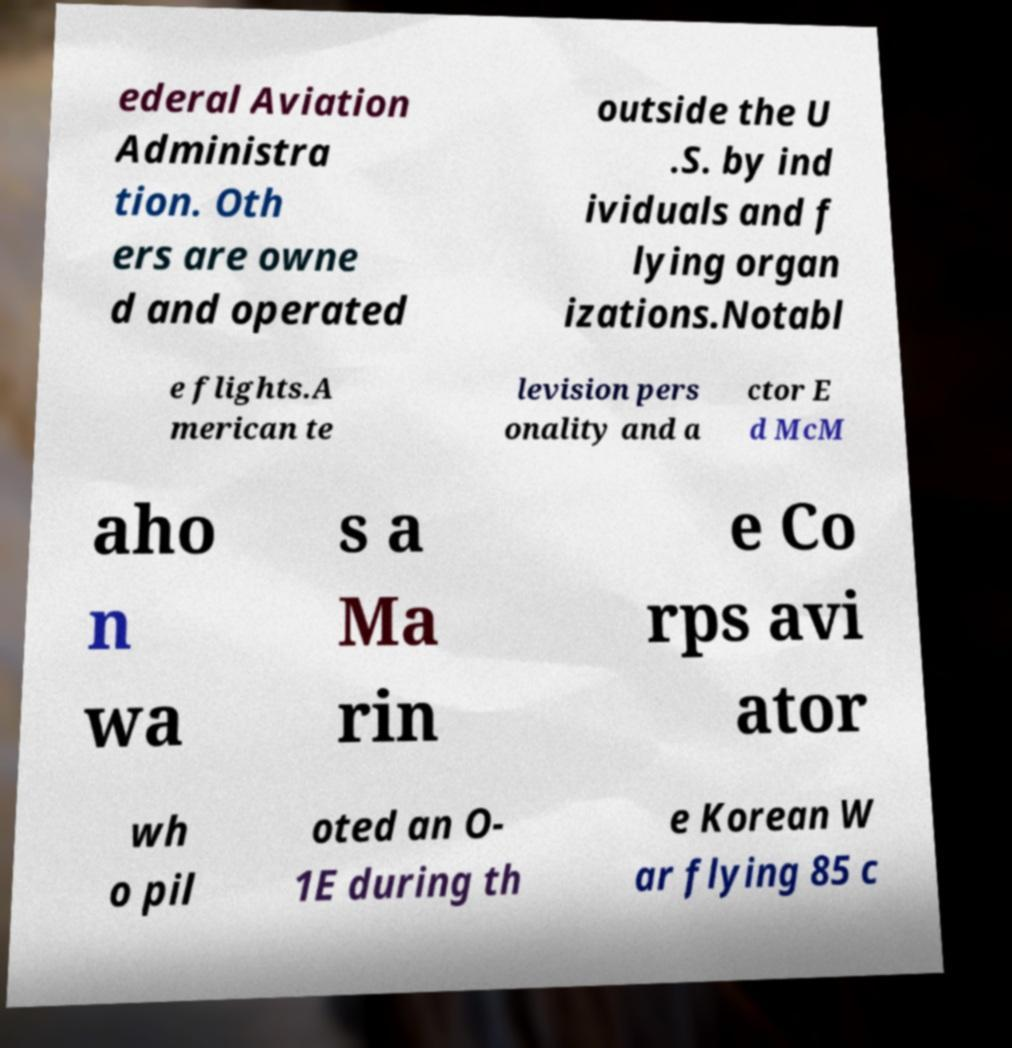Can you accurately transcribe the text from the provided image for me? ederal Aviation Administra tion. Oth ers are owne d and operated outside the U .S. by ind ividuals and f lying organ izations.Notabl e flights.A merican te levision pers onality and a ctor E d McM aho n wa s a Ma rin e Co rps avi ator wh o pil oted an O- 1E during th e Korean W ar flying 85 c 